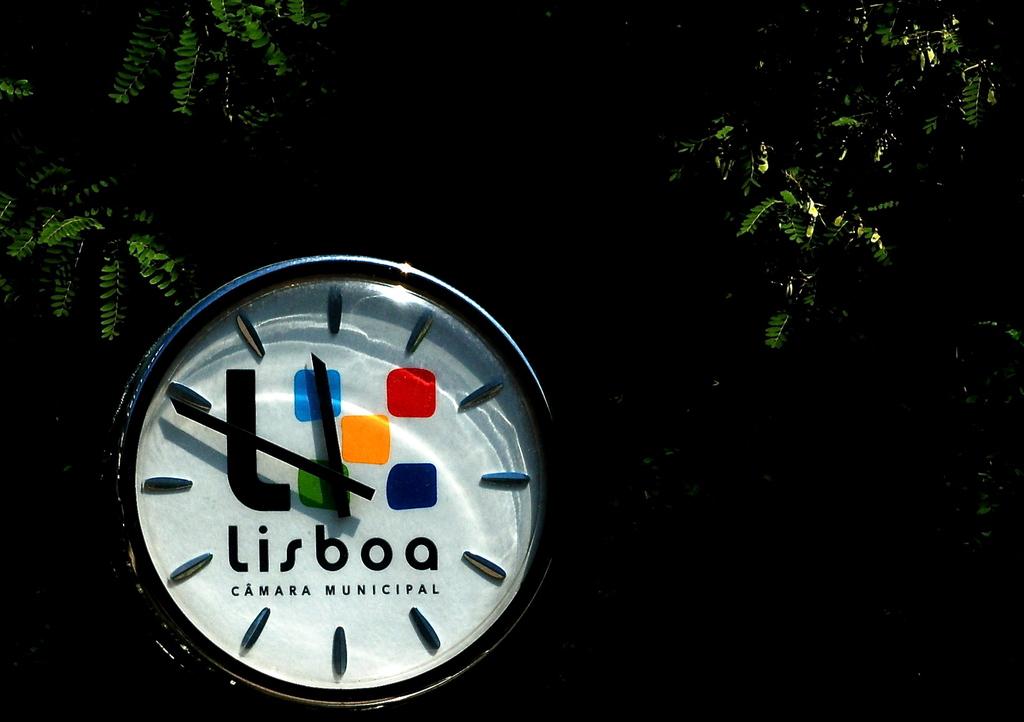The city is lisboa?
Provide a short and direct response. Yes. 